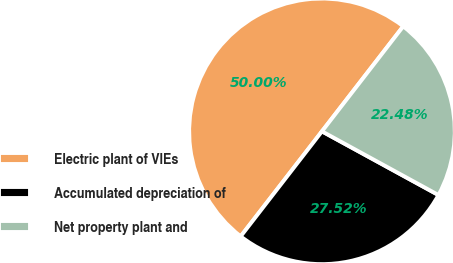Convert chart to OTSL. <chart><loc_0><loc_0><loc_500><loc_500><pie_chart><fcel>Electric plant of VIEs<fcel>Accumulated depreciation of<fcel>Net property plant and<nl><fcel>50.0%<fcel>27.52%<fcel>22.48%<nl></chart> 